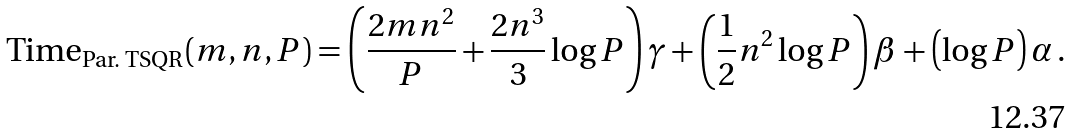Convert formula to latex. <formula><loc_0><loc_0><loc_500><loc_500>\text {Time} _ { \text {Par.\ TSQR} } ( m , n , P ) = \left ( \frac { 2 m n ^ { 2 } } { P } + \frac { 2 n ^ { 3 } } { 3 } \log P \right ) \gamma + \left ( \frac { 1 } { 2 } n ^ { 2 } \log P \right ) \beta + \left ( \log P \right ) \alpha \, .</formula> 